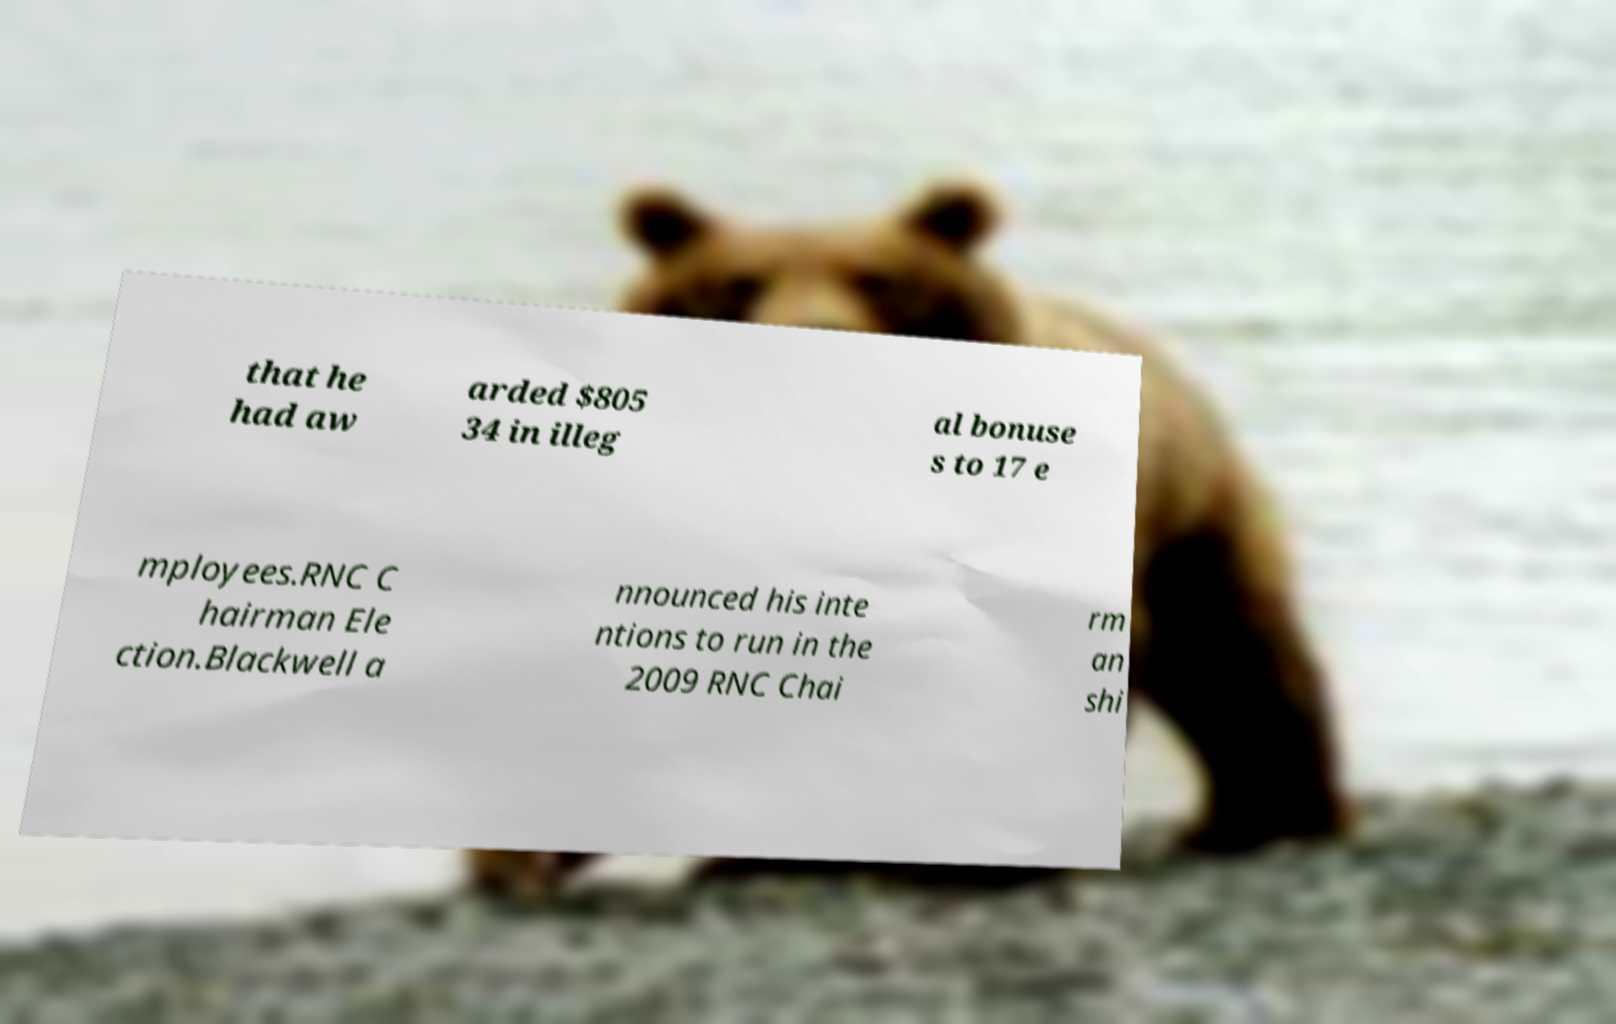What messages or text are displayed in this image? I need them in a readable, typed format. that he had aw arded $805 34 in illeg al bonuse s to 17 e mployees.RNC C hairman Ele ction.Blackwell a nnounced his inte ntions to run in the 2009 RNC Chai rm an shi 